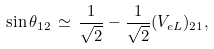<formula> <loc_0><loc_0><loc_500><loc_500>\sin \theta _ { 1 2 } \, \simeq \, \frac { 1 } { \sqrt { 2 } } - \frac { 1 } { \sqrt { 2 } } ( V _ { e L } ) _ { 2 1 } ,</formula> 